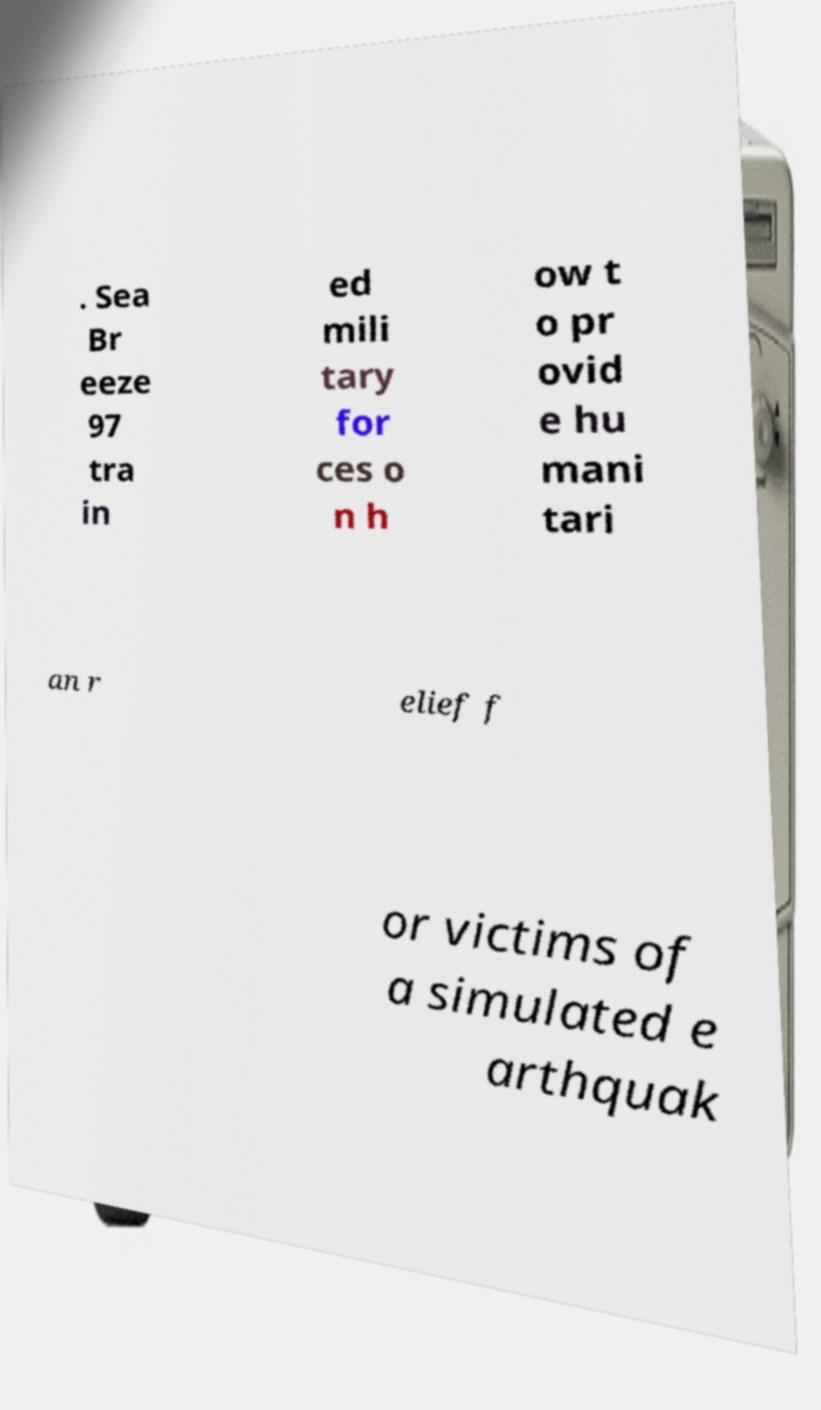Could you assist in decoding the text presented in this image and type it out clearly? . Sea Br eeze 97 tra in ed mili tary for ces o n h ow t o pr ovid e hu mani tari an r elief f or victims of a simulated e arthquak 